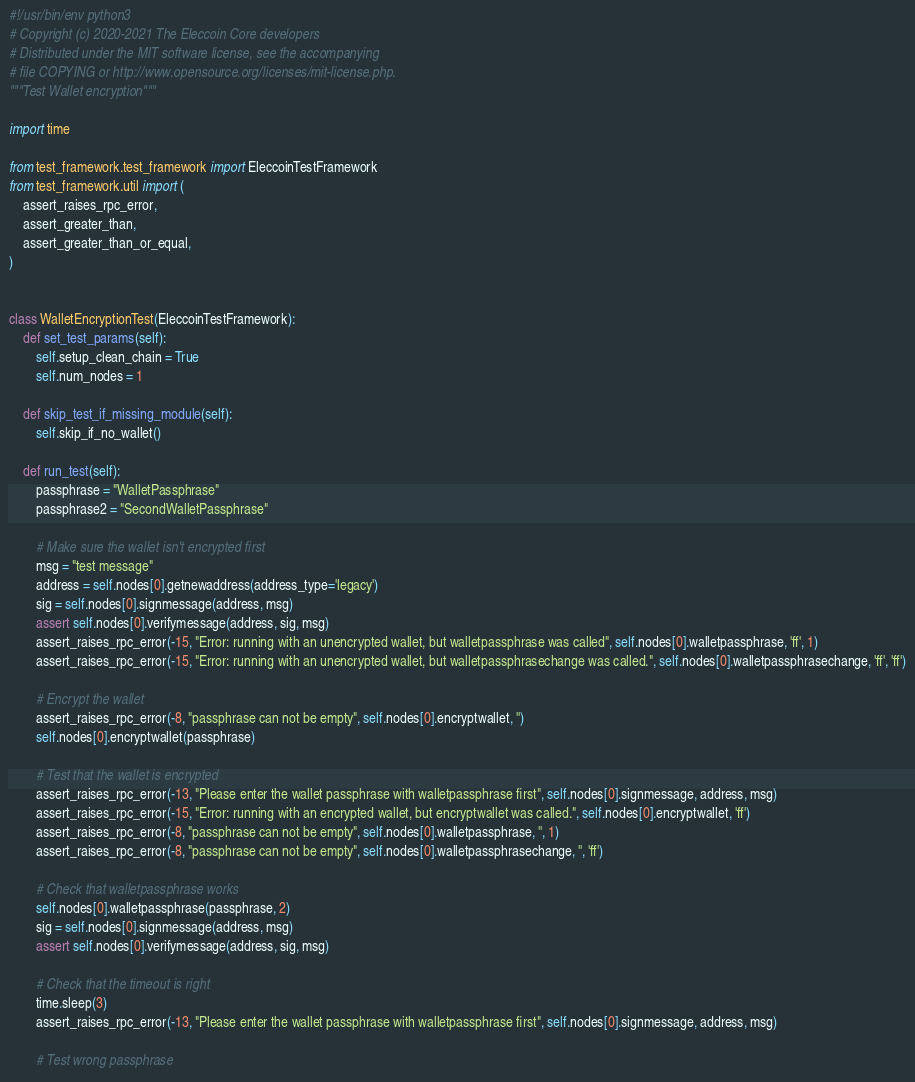Convert code to text. <code><loc_0><loc_0><loc_500><loc_500><_Python_>#!/usr/bin/env python3
# Copyright (c) 2020-2021 The Eleccoin Core developers
# Distributed under the MIT software license, see the accompanying
# file COPYING or http://www.opensource.org/licenses/mit-license.php.
"""Test Wallet encryption"""

import time

from test_framework.test_framework import EleccoinTestFramework
from test_framework.util import (
    assert_raises_rpc_error,
    assert_greater_than,
    assert_greater_than_or_equal,
)


class WalletEncryptionTest(EleccoinTestFramework):
    def set_test_params(self):
        self.setup_clean_chain = True
        self.num_nodes = 1

    def skip_test_if_missing_module(self):
        self.skip_if_no_wallet()

    def run_test(self):
        passphrase = "WalletPassphrase"
        passphrase2 = "SecondWalletPassphrase"

        # Make sure the wallet isn't encrypted first
        msg = "test message"
        address = self.nodes[0].getnewaddress(address_type='legacy')
        sig = self.nodes[0].signmessage(address, msg)
        assert self.nodes[0].verifymessage(address, sig, msg)
        assert_raises_rpc_error(-15, "Error: running with an unencrypted wallet, but walletpassphrase was called", self.nodes[0].walletpassphrase, 'ff', 1)
        assert_raises_rpc_error(-15, "Error: running with an unencrypted wallet, but walletpassphrasechange was called.", self.nodes[0].walletpassphrasechange, 'ff', 'ff')

        # Encrypt the wallet
        assert_raises_rpc_error(-8, "passphrase can not be empty", self.nodes[0].encryptwallet, '')
        self.nodes[0].encryptwallet(passphrase)

        # Test that the wallet is encrypted
        assert_raises_rpc_error(-13, "Please enter the wallet passphrase with walletpassphrase first", self.nodes[0].signmessage, address, msg)
        assert_raises_rpc_error(-15, "Error: running with an encrypted wallet, but encryptwallet was called.", self.nodes[0].encryptwallet, 'ff')
        assert_raises_rpc_error(-8, "passphrase can not be empty", self.nodes[0].walletpassphrase, '', 1)
        assert_raises_rpc_error(-8, "passphrase can not be empty", self.nodes[0].walletpassphrasechange, '', 'ff')

        # Check that walletpassphrase works
        self.nodes[0].walletpassphrase(passphrase, 2)
        sig = self.nodes[0].signmessage(address, msg)
        assert self.nodes[0].verifymessage(address, sig, msg)

        # Check that the timeout is right
        time.sleep(3)
        assert_raises_rpc_error(-13, "Please enter the wallet passphrase with walletpassphrase first", self.nodes[0].signmessage, address, msg)

        # Test wrong passphrase</code> 